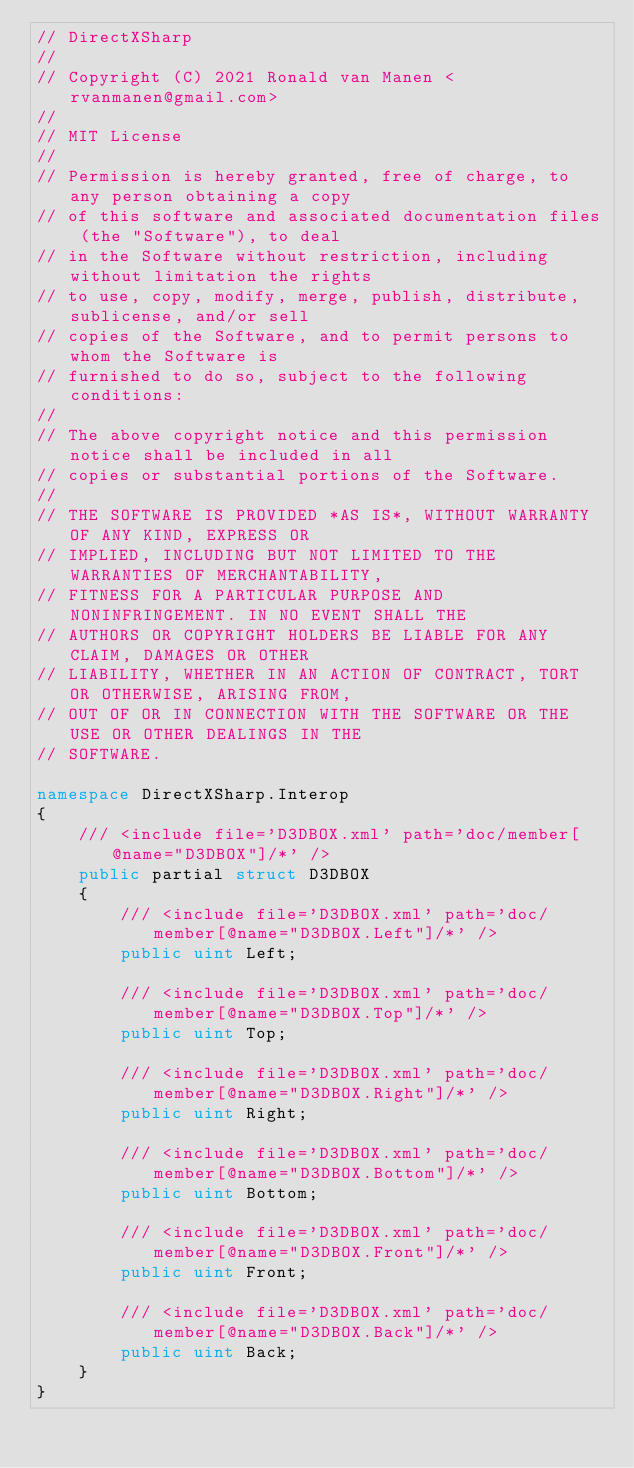Convert code to text. <code><loc_0><loc_0><loc_500><loc_500><_C#_>// DirectXSharp
//
// Copyright (C) 2021 Ronald van Manen <rvanmanen@gmail.com>
//
// MIT License
// 
// Permission is hereby granted, free of charge, to any person obtaining a copy
// of this software and associated documentation files (the "Software"), to deal
// in the Software without restriction, including without limitation the rights
// to use, copy, modify, merge, publish, distribute, sublicense, and/or sell
// copies of the Software, and to permit persons to whom the Software is
// furnished to do so, subject to the following conditions:
// 
// The above copyright notice and this permission notice shall be included in all
// copies or substantial portions of the Software.
// 
// THE SOFTWARE IS PROVIDED *AS IS*, WITHOUT WARRANTY OF ANY KIND, EXPRESS OR
// IMPLIED, INCLUDING BUT NOT LIMITED TO THE WARRANTIES OF MERCHANTABILITY,
// FITNESS FOR A PARTICULAR PURPOSE AND NONINFRINGEMENT. IN NO EVENT SHALL THE
// AUTHORS OR COPYRIGHT HOLDERS BE LIABLE FOR ANY CLAIM, DAMAGES OR OTHER
// LIABILITY, WHETHER IN AN ACTION OF CONTRACT, TORT OR OTHERWISE, ARISING FROM,
// OUT OF OR IN CONNECTION WITH THE SOFTWARE OR THE USE OR OTHER DEALINGS IN THE
// SOFTWARE.

namespace DirectXSharp.Interop
{
    /// <include file='D3DBOX.xml' path='doc/member[@name="D3DBOX"]/*' />
    public partial struct D3DBOX
    {
        /// <include file='D3DBOX.xml' path='doc/member[@name="D3DBOX.Left"]/*' />
        public uint Left;

        /// <include file='D3DBOX.xml' path='doc/member[@name="D3DBOX.Top"]/*' />
        public uint Top;

        /// <include file='D3DBOX.xml' path='doc/member[@name="D3DBOX.Right"]/*' />
        public uint Right;

        /// <include file='D3DBOX.xml' path='doc/member[@name="D3DBOX.Bottom"]/*' />
        public uint Bottom;

        /// <include file='D3DBOX.xml' path='doc/member[@name="D3DBOX.Front"]/*' />
        public uint Front;

        /// <include file='D3DBOX.xml' path='doc/member[@name="D3DBOX.Back"]/*' />
        public uint Back;
    }
}
</code> 